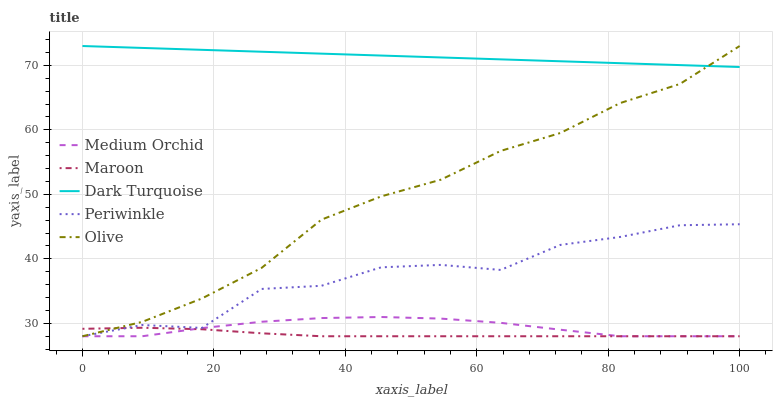Does Maroon have the minimum area under the curve?
Answer yes or no. Yes. Does Medium Orchid have the minimum area under the curve?
Answer yes or no. No. Does Medium Orchid have the maximum area under the curve?
Answer yes or no. No. Is Periwinkle the roughest?
Answer yes or no. Yes. Is Medium Orchid the smoothest?
Answer yes or no. No. Is Medium Orchid the roughest?
Answer yes or no. No. Does Dark Turquoise have the lowest value?
Answer yes or no. No. Does Medium Orchid have the highest value?
Answer yes or no. No. Is Medium Orchid less than Dark Turquoise?
Answer yes or no. Yes. Is Dark Turquoise greater than Periwinkle?
Answer yes or no. Yes. Does Medium Orchid intersect Dark Turquoise?
Answer yes or no. No. 